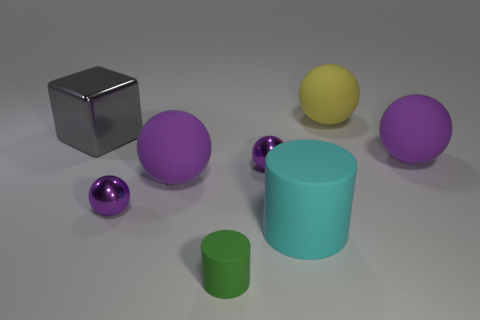How many purple spheres must be subtracted to get 3 purple spheres? 1 Subtract all green cylinders. How many purple spheres are left? 4 Subtract all yellow balls. How many balls are left? 4 Subtract all large yellow balls. How many balls are left? 4 Subtract all brown spheres. Subtract all red cylinders. How many spheres are left? 5 Add 2 tiny purple metal objects. How many objects exist? 10 Subtract all cylinders. How many objects are left? 6 Subtract 0 cyan balls. How many objects are left? 8 Subtract all green spheres. Subtract all yellow rubber objects. How many objects are left? 7 Add 5 cyan rubber cylinders. How many cyan rubber cylinders are left? 6 